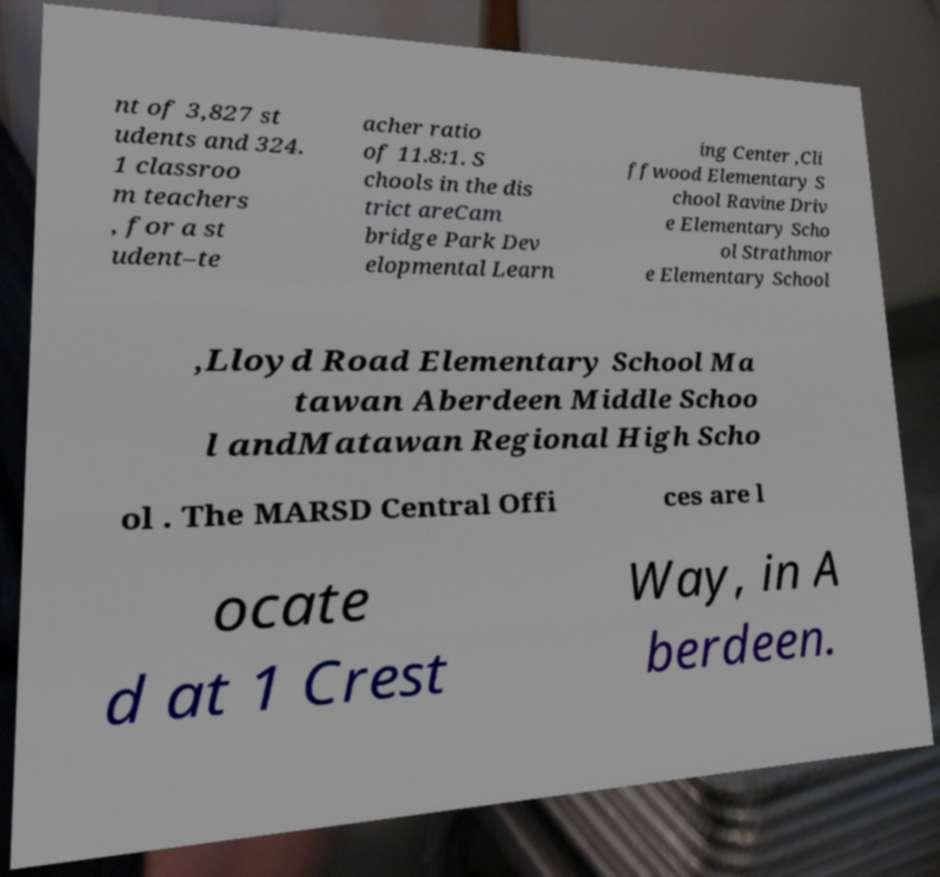What messages or text are displayed in this image? I need them in a readable, typed format. nt of 3,827 st udents and 324. 1 classroo m teachers , for a st udent–te acher ratio of 11.8:1. S chools in the dis trict areCam bridge Park Dev elopmental Learn ing Center ,Cli ffwood Elementary S chool Ravine Driv e Elementary Scho ol Strathmor e Elementary School ,Lloyd Road Elementary School Ma tawan Aberdeen Middle Schoo l andMatawan Regional High Scho ol . The MARSD Central Offi ces are l ocate d at 1 Crest Way, in A berdeen. 